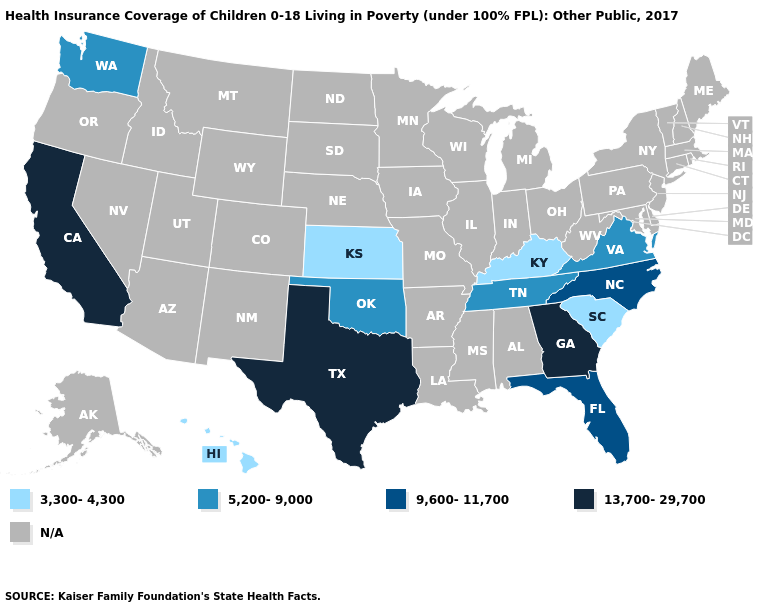What is the value of Wisconsin?
Concise answer only. N/A. What is the lowest value in states that border Alabama?
Give a very brief answer. 5,200-9,000. Name the states that have a value in the range 5,200-9,000?
Concise answer only. Oklahoma, Tennessee, Virginia, Washington. Which states have the lowest value in the USA?
Give a very brief answer. Hawaii, Kansas, Kentucky, South Carolina. Name the states that have a value in the range 5,200-9,000?
Short answer required. Oklahoma, Tennessee, Virginia, Washington. What is the value of Arkansas?
Concise answer only. N/A. Does California have the highest value in the West?
Write a very short answer. Yes. Among the states that border West Virginia , which have the lowest value?
Write a very short answer. Kentucky. What is the value of New Mexico?
Quick response, please. N/A. What is the value of Nevada?
Keep it brief. N/A. What is the value of Nebraska?
Quick response, please. N/A. What is the value of Florida?
Quick response, please. 9,600-11,700. 